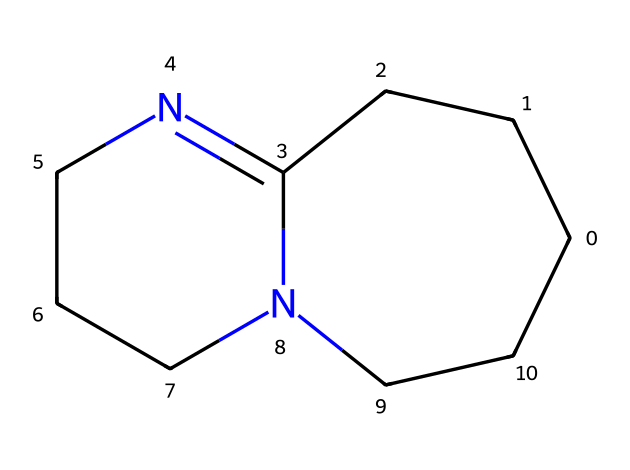What is the molecular formula of DBU? By analyzing the structure, we can count the number of carbon (C), hydrogen (H), nitrogen (N), and other atoms present. The structure has 11 carbons, 18 hydrogens, and 2 nitrogens, leading to the molecular formula C11H18N2.
Answer: C11H18N2 How many rings are present in the structure of DBU? Looking at the structure, we see that the molecule features two fused rings. Counting them gives us a total of two rings.
Answer: 2 What feature in DBU contributes to its basicity? The presence of the lone pairs of electrons on the nitrogen atoms in the bicyclic structure allows DBU to act as a strong base by accepting protons (H+).
Answer: nitrogen lone pairs What type of reaction is DBU commonly used for in pharmaceutical syntheses? DBU is often employed in deprotonation reactions due to its high basicity, facilitating nucleophilic substitution and other transformations in synthetic routes.
Answer: deprotonation Which atoms contribute to the curvature of the bicyclic structure in DBU? The curvature of the bicyclic structure is formed by the carbon atoms in the rings and the nitrogen atoms, specifically where they create the bicyclo configuration.
Answer: carbon and nitrogen What role do the nitrogen atoms play in DBU's chemical behavior? The nitrogen atoms in DBU contribute to its superbase characteristics by providing basic sites that can readily accept protons, enhancing its reactivity in various chemical processes.
Answer: basic sites 